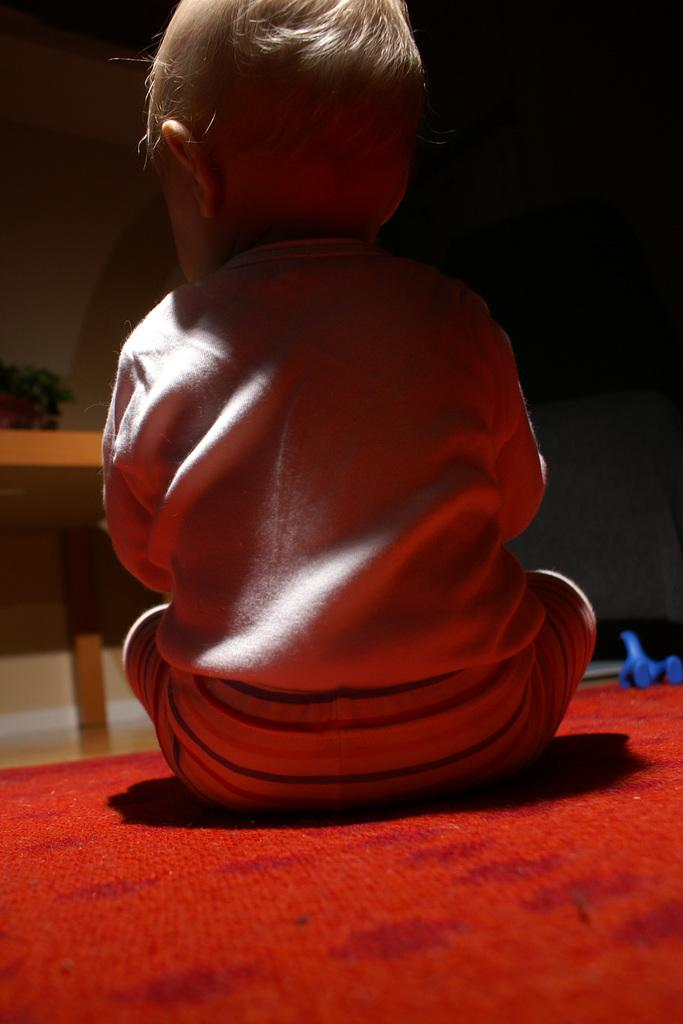Who is the main subject in the image? There is a child in the image. What is the child sitting on? The child is sitting on a red color surface. Can you describe the background of the image? The background of the image is dark. What type of boot is the minister wearing in the image? There is no minister or boot present in the image; it features a child sitting on a red surface with a dark background. 